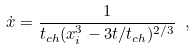<formula> <loc_0><loc_0><loc_500><loc_500>\dot { x } = \frac { 1 } { t _ { c h } ( x _ { i } ^ { 3 } - 3 t / t _ { c h } ) ^ { 2 / 3 } } \ ,</formula> 